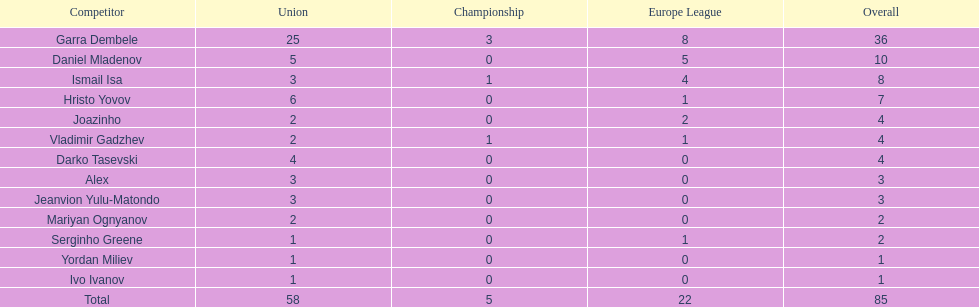Who had the most goal scores? Garra Dembele. 